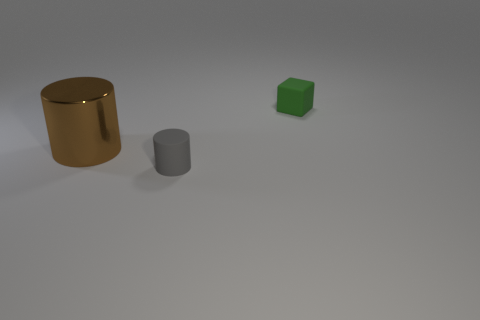Add 3 small green rubber things. How many objects exist? 6 Subtract 0 cyan cylinders. How many objects are left? 3 Subtract all cylinders. How many objects are left? 1 Subtract 1 cylinders. How many cylinders are left? 1 Subtract all yellow blocks. Subtract all purple spheres. How many blocks are left? 1 Subtract all blue balls. How many brown cylinders are left? 1 Subtract all tiny blue objects. Subtract all small cylinders. How many objects are left? 2 Add 3 small matte objects. How many small matte objects are left? 5 Add 3 big red shiny cylinders. How many big red shiny cylinders exist? 3 Subtract all brown cylinders. How many cylinders are left? 1 